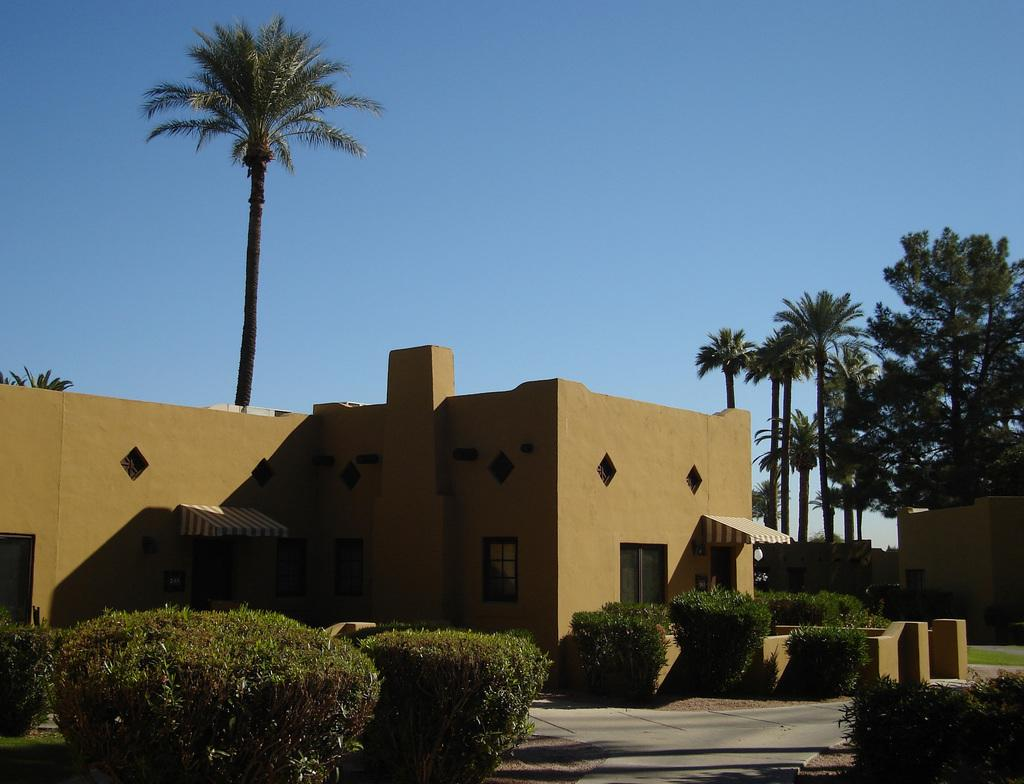What type of structure is visible in the image? There is a house in the image. What can be seen around the house? There are plants and trees around the house. How many types of vegetation are visible around the house? There are two types of vegetation visible around the house: plants and trees. How much profit does the house generate in the image? The image does not provide any information about the profit generated by the house. 